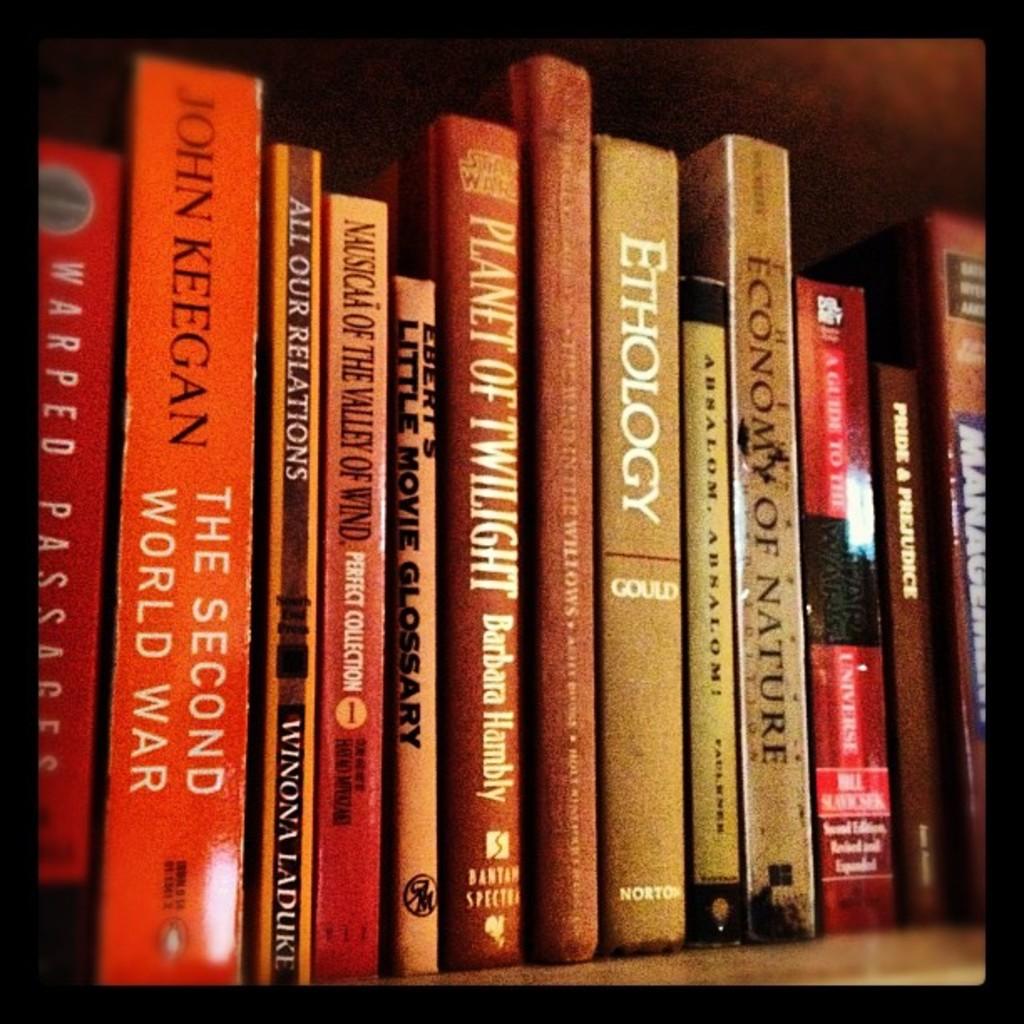Who wrote the second world war?
Ensure brevity in your answer.  John keegan. 